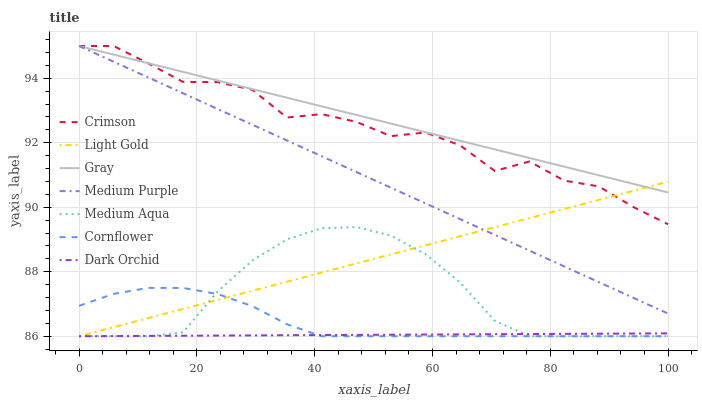Does Dark Orchid have the minimum area under the curve?
Answer yes or no. Yes. Does Gray have the maximum area under the curve?
Answer yes or no. Yes. Does Cornflower have the minimum area under the curve?
Answer yes or no. No. Does Cornflower have the maximum area under the curve?
Answer yes or no. No. Is Medium Purple the smoothest?
Answer yes or no. Yes. Is Crimson the roughest?
Answer yes or no. Yes. Is Cornflower the smoothest?
Answer yes or no. No. Is Cornflower the roughest?
Answer yes or no. No. Does Medium Purple have the lowest value?
Answer yes or no. No. Does Crimson have the highest value?
Answer yes or no. Yes. Does Cornflower have the highest value?
Answer yes or no. No. Is Dark Orchid less than Gray?
Answer yes or no. Yes. Is Medium Purple greater than Medium Aqua?
Answer yes or no. Yes. Does Light Gold intersect Gray?
Answer yes or no. Yes. Is Light Gold less than Gray?
Answer yes or no. No. Is Light Gold greater than Gray?
Answer yes or no. No. Does Dark Orchid intersect Gray?
Answer yes or no. No. 